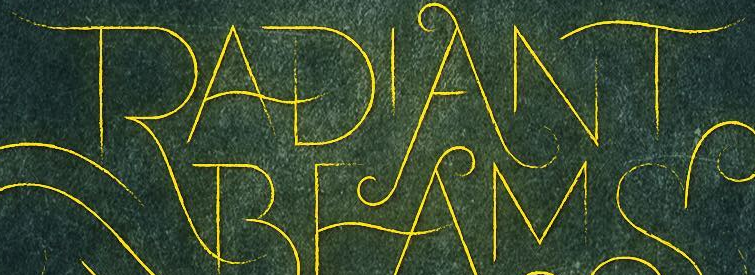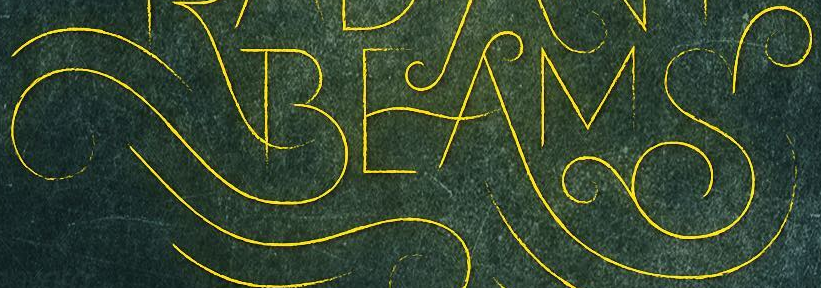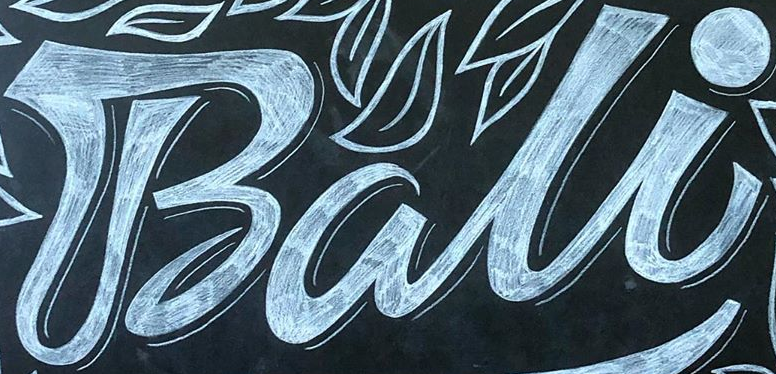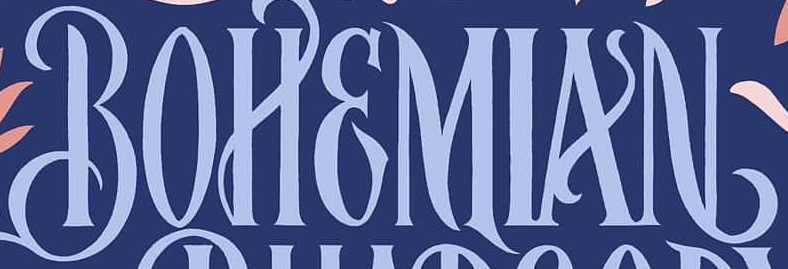Read the text from these images in sequence, separated by a semicolon. RADIANT; BEAMS; Bali; BOHEMIAN 